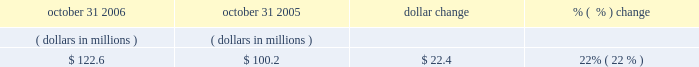Accounts receivable , net october 31 , 2006 october 31 , 2005 dollar change change .
The increase in accounts receivable was primarily due to the increased billings during the fiscal year ended october 31 , 2006 .
Days sales outstanding ( dso ) was 39 days at october 31 , 2006 and 36 days at october 31 , 2005 .
Our accounts receivable and dso are primarily driven by our billing and collections activities .
Net working capital working capital is comprised of current assets less current liabilities , as shown on our balance sheet .
As of october 31 , 2006 , our working capital was $ 23.4 million , compared to $ 130.6 million as of october 31 , 2005 .
The decrease in net working capital of $ 107.2 million was primarily due to ( 1 ) a decrease of $ 73.7 million in cash and cash equivalents ; ( 2 ) a decrease of current deferred tax assets of $ 83.2 million , primarily due to a tax accounting method change ; ( 3 ) a decrease in income taxes receivable of $ 5.8 million ; ( 4 ) an increase in income taxes payable of $ 21.5 million ; ( 5 ) an increase in deferred revenue of $ 29.9 million ; and ( 6 ) a net increase of $ 2.8 million in accounts payable and other liabilities which included a reclassification of debt of $ 7.5 million from long term to short term debt .
This decrease was partially offset by ( 1 ) an increase in short-term investments of $ 59.9 million ; ( 2 ) an increase in prepaid and other assets of $ 27.4 million , which includes land of $ 23.4 million reclassified from property plant and equipment to asset held for sale within prepaid expense and other assets on our consolidated balance sheet ; and ( 3 ) an increase in accounts receivable of $ 22.4 million .
Other commitments 2014revolving credit facility on october 20 , 2006 , we entered into a five-year , $ 300.0 million senior unsecured revolving credit facility providing for loans to synopsys and certain of its foreign subsidiaries .
The facility replaces our previous $ 250.0 million senior unsecured credit facility , which was terminated effective october 20 , 2006 .
The amount of the facility may be increased by up to an additional $ 150.0 million through the fourth year of the facility .
The facility contains financial covenants requiring us to maintain a minimum leverage ratio and specified levels of cash , as well as other non-financial covenants .
The facility terminates on october 20 , 2011 .
Borrowings under the facility bear interest at the greater of the administrative agent 2019s prime rate or the federal funds rate plus 0.50% ( 0.50 % ) ; however , we have the option to pay interest based on the outstanding amount at eurodollar rates plus a spread between 0.50% ( 0.50 % ) and 0.70% ( 0.70 % ) based on a pricing grid tied to a financial covenant .
In addition , commitment fees are payable on the facility at rates between 0.125% ( 0.125 % ) and 0.175% ( 0.175 % ) per year based on a pricing grid tied to a financial covenant .
As of october 31 , 2006 we had no outstanding borrowings under this credit facility and were in compliance with all the covenants .
We believe that our current cash , cash equivalents , short-term investments , cash generated from operations , and available credit under our credit facility will satisfy our business requirements for at least the next twelve months. .
Considering the year 2006 , what is the percentage of working capital among the total accounts receivable? 
Rationale: it is the value of the working capital divided by the total accounts receivable , then turned into a percentage .
Computations: (23.4 / 122.6)
Answer: 0.19086. 